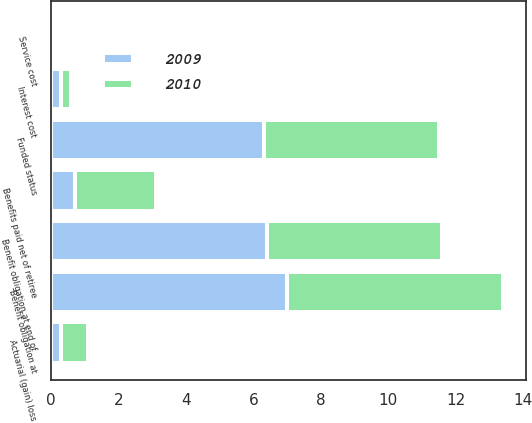<chart> <loc_0><loc_0><loc_500><loc_500><stacked_bar_chart><ecel><fcel>Benefit obligation at<fcel>Service cost<fcel>Interest cost<fcel>Actuarial (gain) loss<fcel>Benefits paid net of retiree<fcel>Benefit obligation at end of<fcel>Funded status<nl><fcel>2010<fcel>6.4<fcel>0.1<fcel>0.3<fcel>0.8<fcel>2.4<fcel>5.2<fcel>5.2<nl><fcel>2009<fcel>7<fcel>0.1<fcel>0.3<fcel>0.3<fcel>0.7<fcel>6.4<fcel>6.3<nl></chart> 